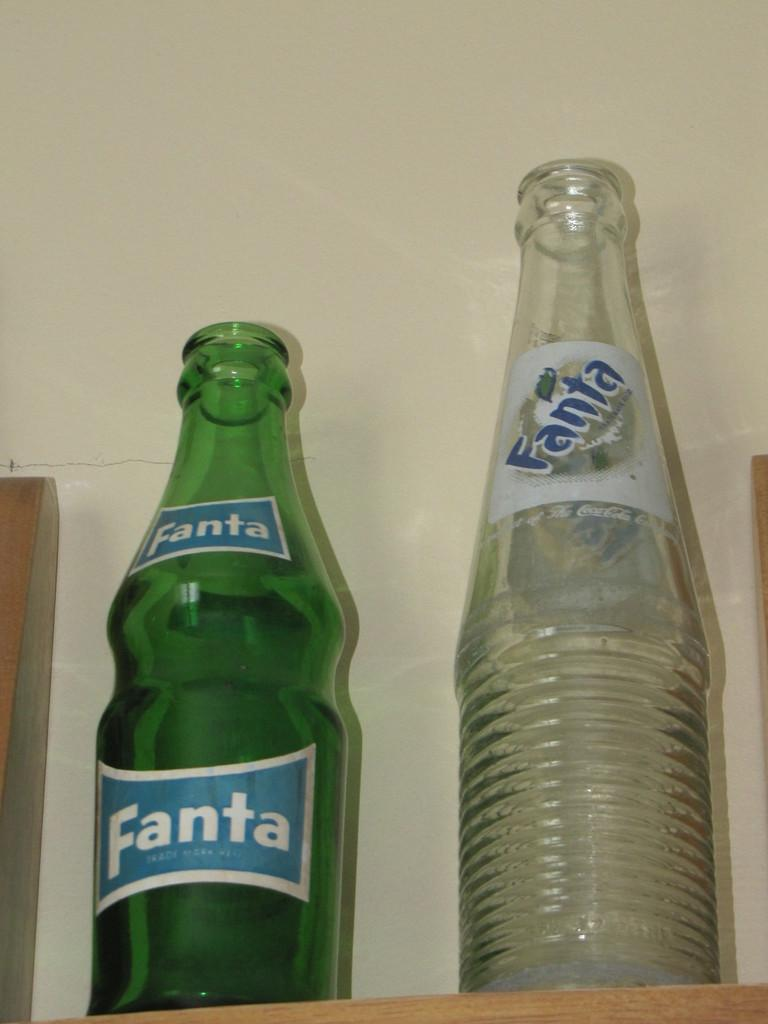What type of bottles are in the image? There are two Fant bottles in the image. What colors are the bottles? One bottle is green, and the other is white. Where are the bottles located? The bottles are on a table. What type of airport is visible in the image? There is no airport present in the image; it features two Fant bottles on a table. What role does the weight of the bottles play in the image? The weight of the bottles is not mentioned or relevant in the image, as it only shows the bottles' colors and location. 